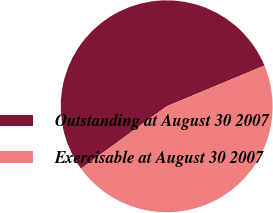Convert chart to OTSL. <chart><loc_0><loc_0><loc_500><loc_500><pie_chart><fcel>Outstanding at August 30 2007<fcel>Exercisable at August 30 2007<nl><fcel>53.73%<fcel>46.27%<nl></chart> 